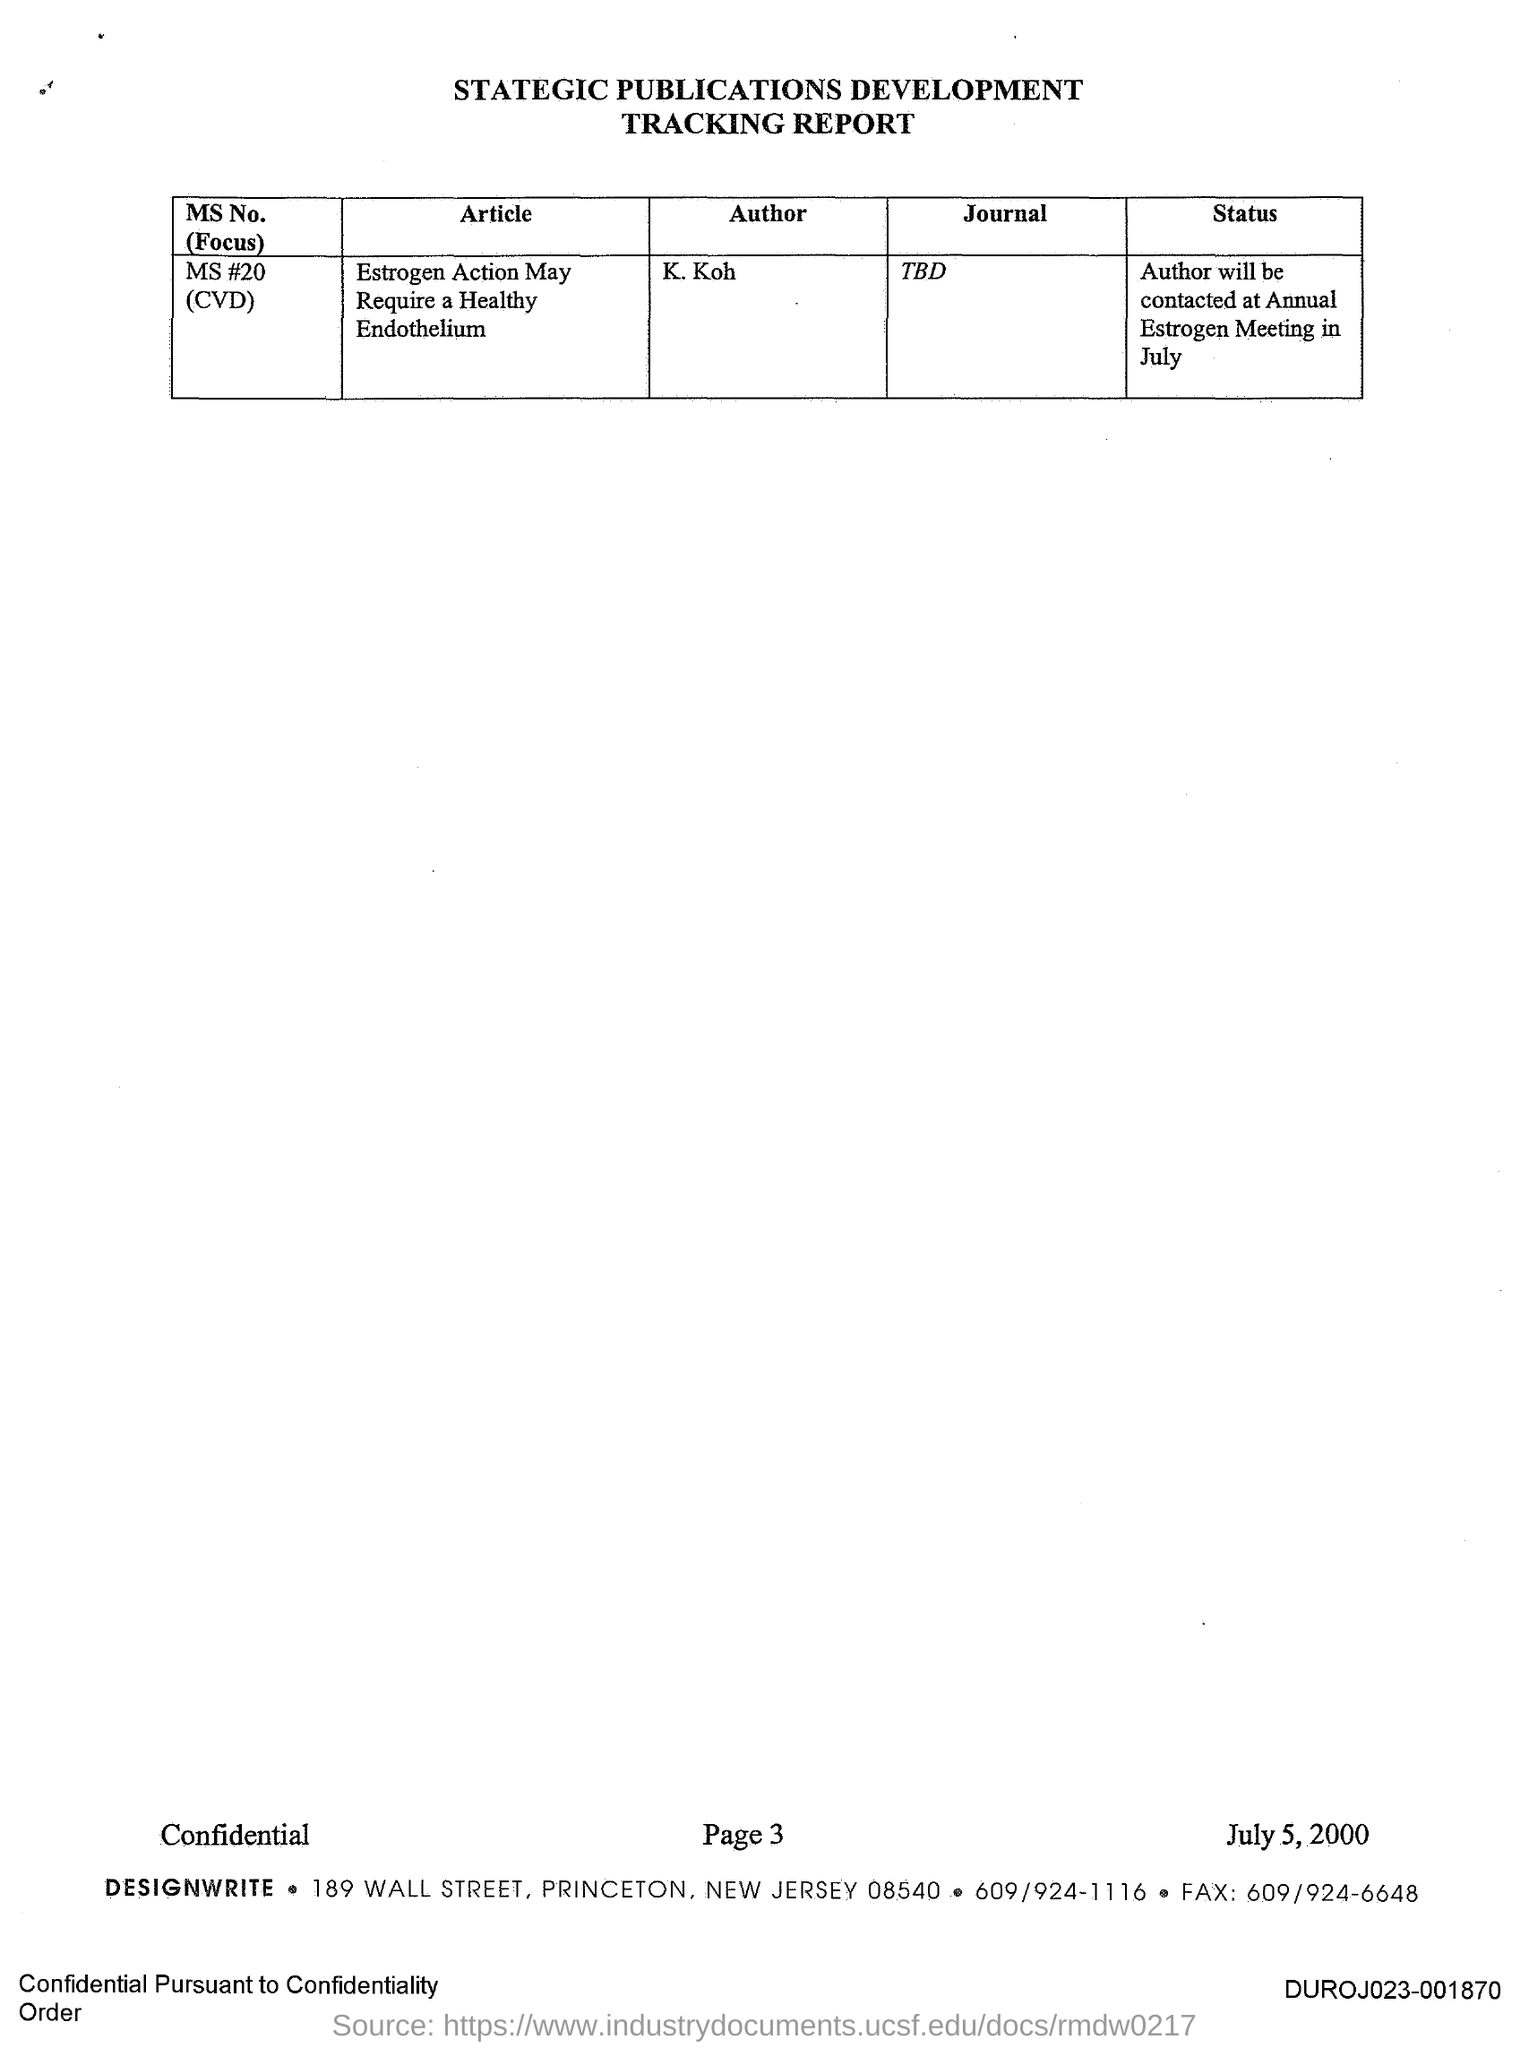Specify some key components in this picture. K. Koh is the author of the journal. The ms number 20 is associated with a journal that has yet to be determined. 